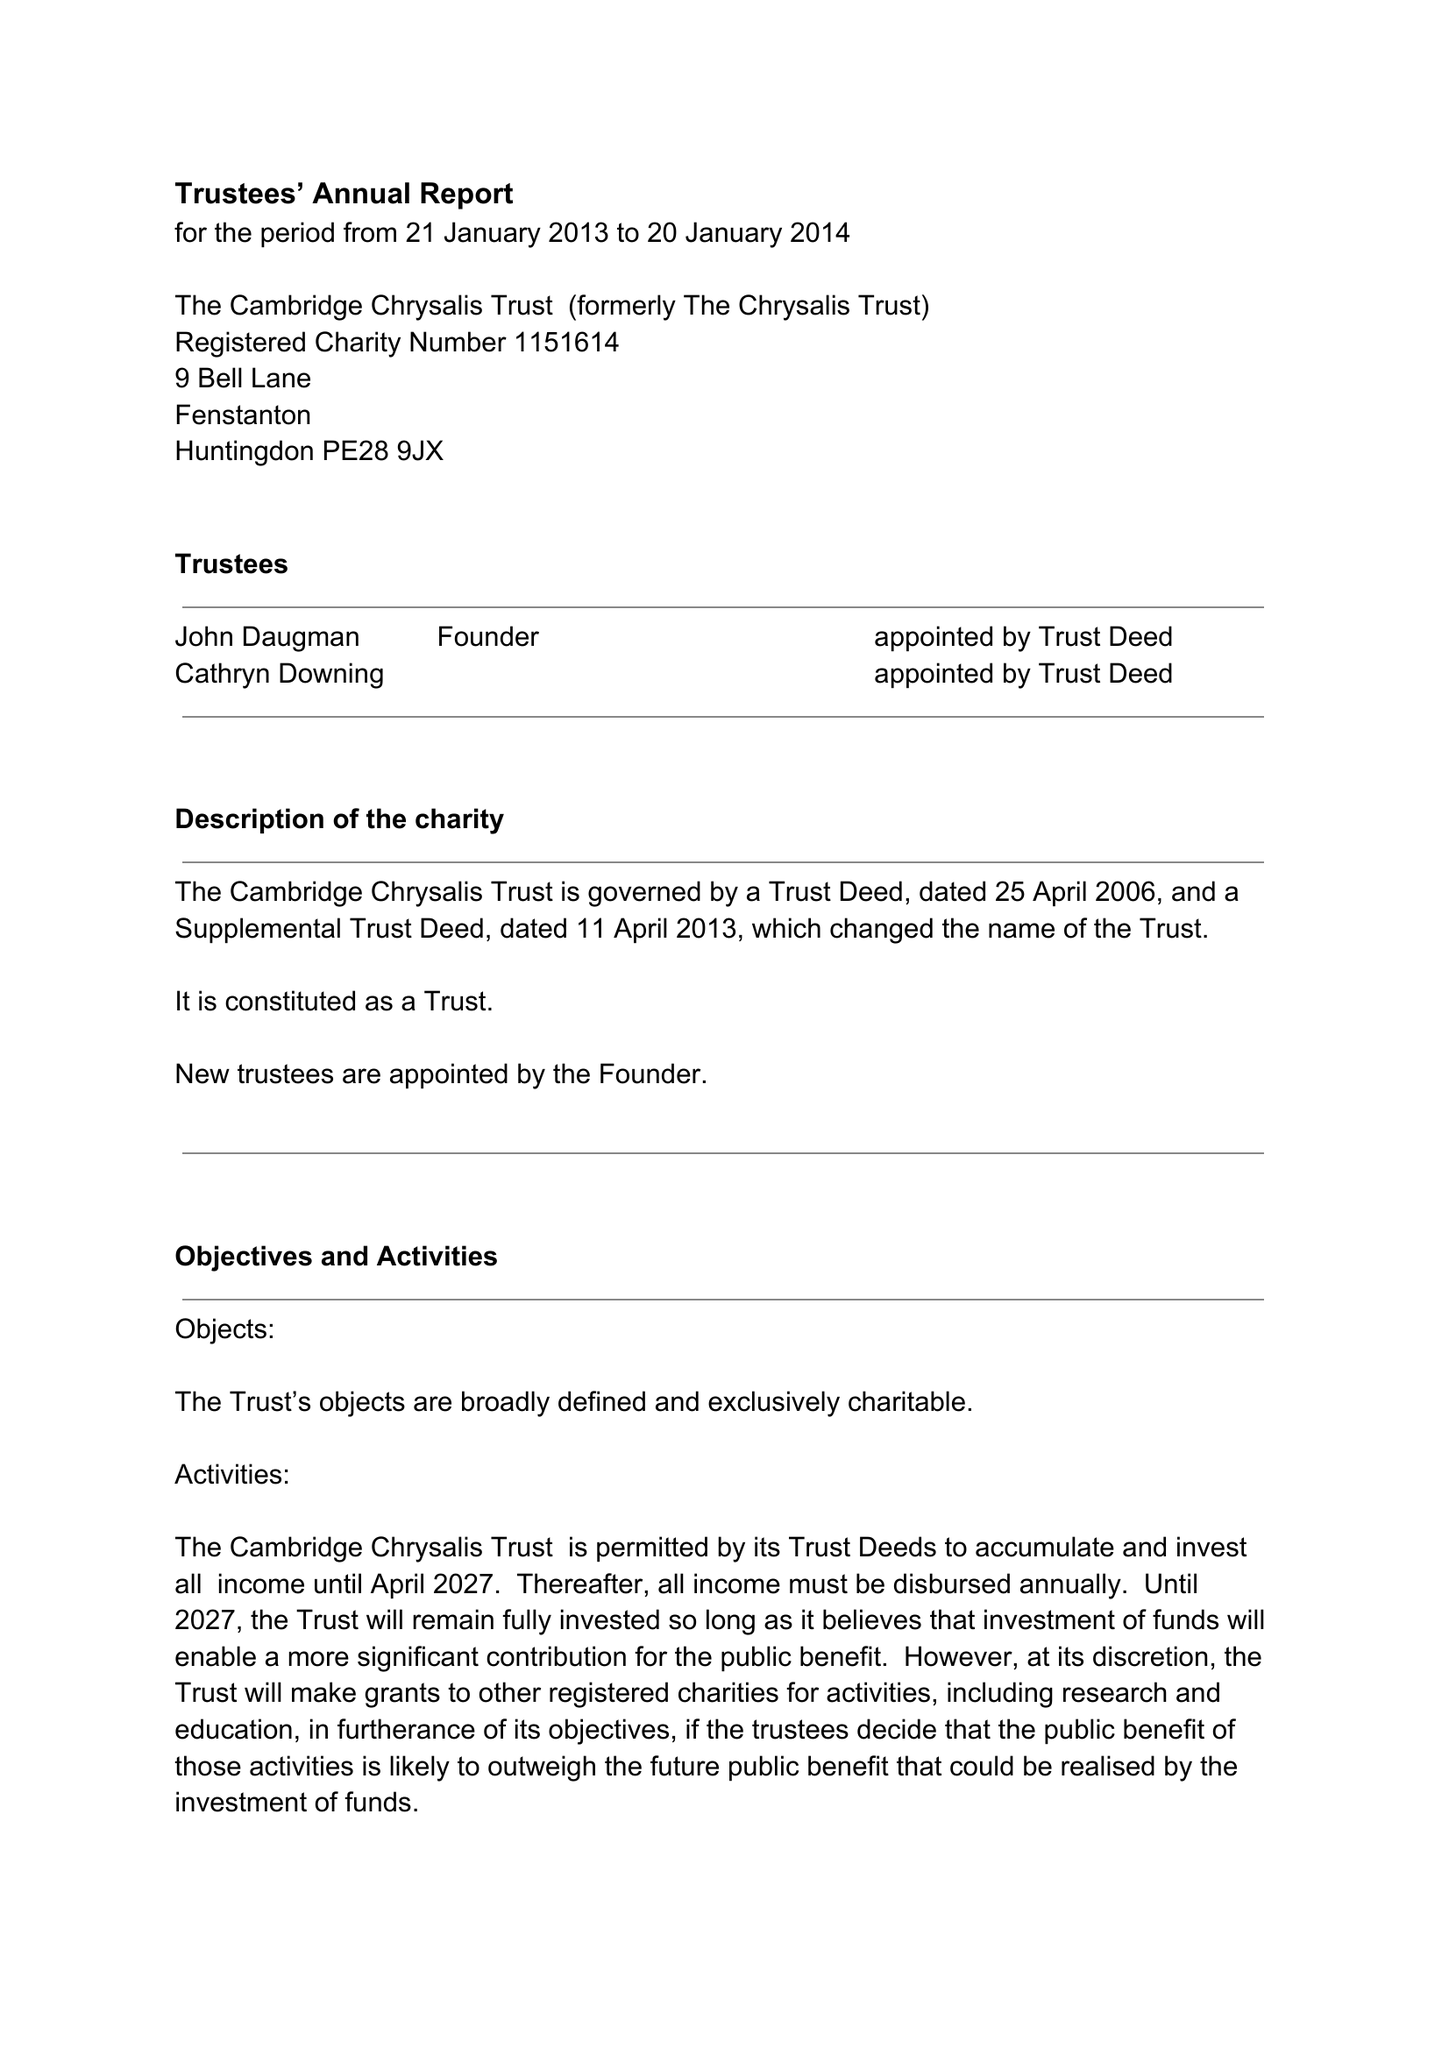What is the value for the address__postcode?
Answer the question using a single word or phrase. PE28 9JX 